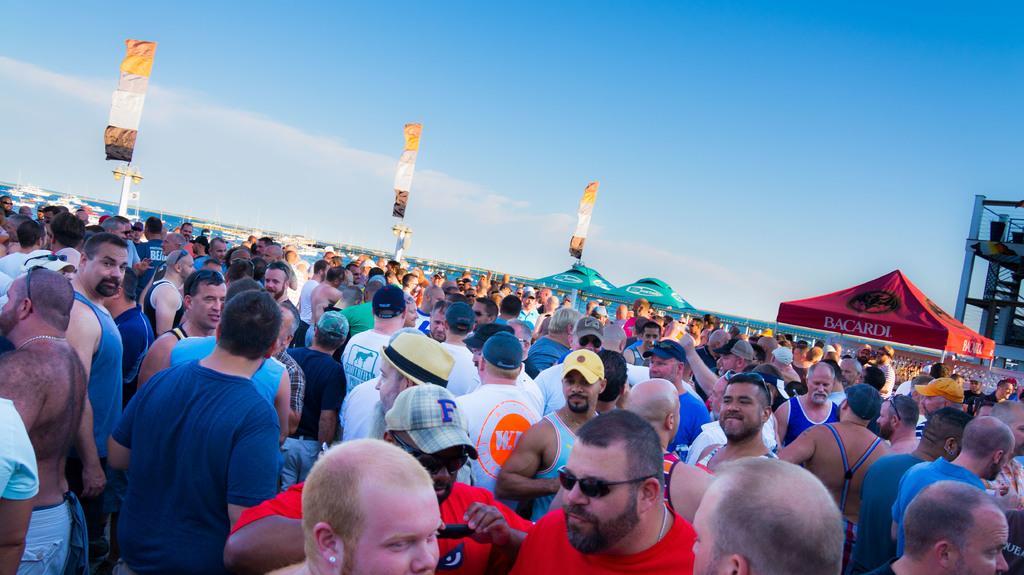How would you summarize this image in a sentence or two? In this image we can see group of persons standing. Behind the persons we can see the poles with flags. On the right of the image we can see a tent and a building. At the top we can see the sky. In the middle of the image we can see water and few boats. 